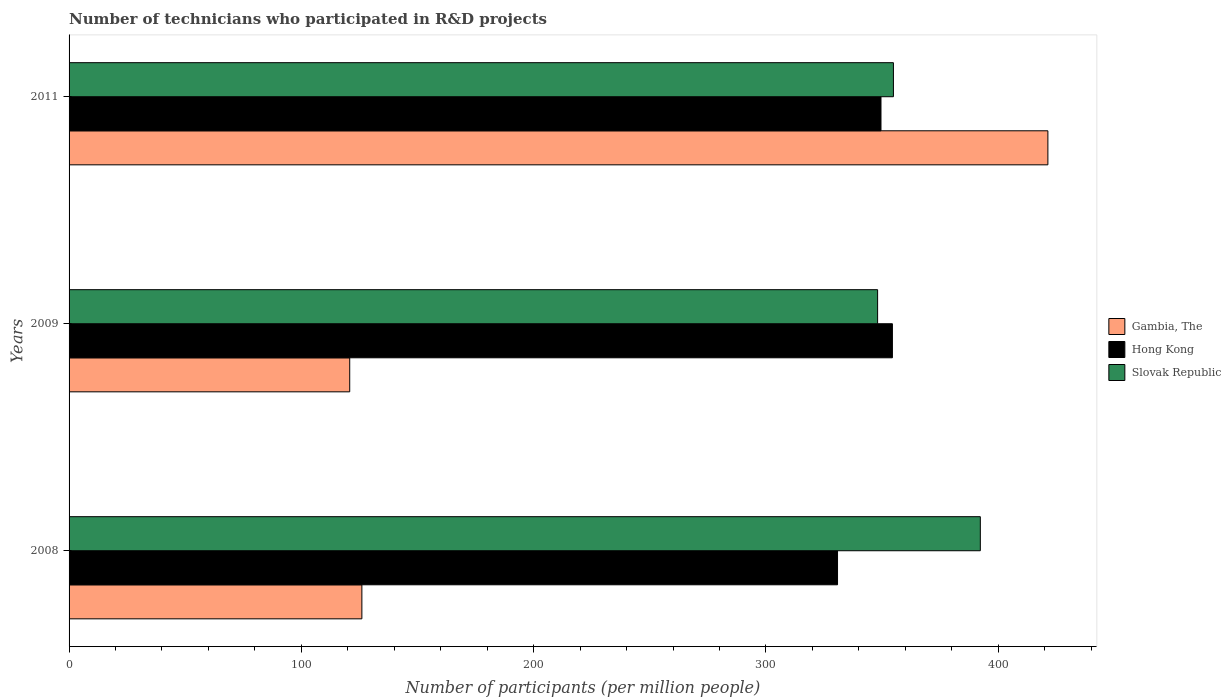How many different coloured bars are there?
Make the answer very short. 3. How many bars are there on the 1st tick from the top?
Offer a terse response. 3. What is the label of the 3rd group of bars from the top?
Make the answer very short. 2008. What is the number of technicians who participated in R&D projects in Hong Kong in 2011?
Keep it short and to the point. 349.51. Across all years, what is the maximum number of technicians who participated in R&D projects in Hong Kong?
Your answer should be very brief. 354.43. Across all years, what is the minimum number of technicians who participated in R&D projects in Gambia, The?
Provide a succinct answer. 120.81. In which year was the number of technicians who participated in R&D projects in Hong Kong maximum?
Ensure brevity in your answer.  2009. What is the total number of technicians who participated in R&D projects in Slovak Republic in the graph?
Offer a very short reply. 1095.2. What is the difference between the number of technicians who participated in R&D projects in Gambia, The in 2009 and that in 2011?
Make the answer very short. -300.55. What is the difference between the number of technicians who participated in R&D projects in Gambia, The in 2011 and the number of technicians who participated in R&D projects in Hong Kong in 2008?
Provide a short and direct response. 90.55. What is the average number of technicians who participated in R&D projects in Gambia, The per year?
Give a very brief answer. 222.74. In the year 2008, what is the difference between the number of technicians who participated in R&D projects in Gambia, The and number of technicians who participated in R&D projects in Hong Kong?
Offer a terse response. -204.76. In how many years, is the number of technicians who participated in R&D projects in Gambia, The greater than 140 ?
Your answer should be very brief. 1. What is the ratio of the number of technicians who participated in R&D projects in Hong Kong in 2008 to that in 2009?
Keep it short and to the point. 0.93. Is the number of technicians who participated in R&D projects in Slovak Republic in 2009 less than that in 2011?
Offer a terse response. Yes. What is the difference between the highest and the second highest number of technicians who participated in R&D projects in Slovak Republic?
Offer a very short reply. 37.41. What is the difference between the highest and the lowest number of technicians who participated in R&D projects in Hong Kong?
Offer a very short reply. 23.62. In how many years, is the number of technicians who participated in R&D projects in Hong Kong greater than the average number of technicians who participated in R&D projects in Hong Kong taken over all years?
Provide a short and direct response. 2. What does the 1st bar from the top in 2011 represents?
Offer a very short reply. Slovak Republic. What does the 2nd bar from the bottom in 2009 represents?
Provide a short and direct response. Hong Kong. Is it the case that in every year, the sum of the number of technicians who participated in R&D projects in Gambia, The and number of technicians who participated in R&D projects in Slovak Republic is greater than the number of technicians who participated in R&D projects in Hong Kong?
Give a very brief answer. Yes. How many years are there in the graph?
Your response must be concise. 3. Does the graph contain any zero values?
Make the answer very short. No. Does the graph contain grids?
Ensure brevity in your answer.  No. How many legend labels are there?
Offer a very short reply. 3. What is the title of the graph?
Provide a short and direct response. Number of technicians who participated in R&D projects. What is the label or title of the X-axis?
Your answer should be compact. Number of participants (per million people). What is the label or title of the Y-axis?
Give a very brief answer. Years. What is the Number of participants (per million people) in Gambia, The in 2008?
Ensure brevity in your answer.  126.04. What is the Number of participants (per million people) of Hong Kong in 2008?
Your answer should be very brief. 330.81. What is the Number of participants (per million people) in Slovak Republic in 2008?
Give a very brief answer. 392.28. What is the Number of participants (per million people) of Gambia, The in 2009?
Provide a succinct answer. 120.81. What is the Number of participants (per million people) in Hong Kong in 2009?
Your answer should be compact. 354.43. What is the Number of participants (per million people) in Slovak Republic in 2009?
Provide a succinct answer. 348.06. What is the Number of participants (per million people) of Gambia, The in 2011?
Your answer should be very brief. 421.36. What is the Number of participants (per million people) of Hong Kong in 2011?
Your response must be concise. 349.51. What is the Number of participants (per million people) of Slovak Republic in 2011?
Your answer should be compact. 354.86. Across all years, what is the maximum Number of participants (per million people) of Gambia, The?
Your response must be concise. 421.36. Across all years, what is the maximum Number of participants (per million people) in Hong Kong?
Provide a short and direct response. 354.43. Across all years, what is the maximum Number of participants (per million people) in Slovak Republic?
Provide a short and direct response. 392.28. Across all years, what is the minimum Number of participants (per million people) of Gambia, The?
Provide a short and direct response. 120.81. Across all years, what is the minimum Number of participants (per million people) of Hong Kong?
Offer a terse response. 330.81. Across all years, what is the minimum Number of participants (per million people) in Slovak Republic?
Your answer should be compact. 348.06. What is the total Number of participants (per million people) in Gambia, The in the graph?
Ensure brevity in your answer.  668.22. What is the total Number of participants (per million people) in Hong Kong in the graph?
Provide a succinct answer. 1034.74. What is the total Number of participants (per million people) of Slovak Republic in the graph?
Provide a short and direct response. 1095.2. What is the difference between the Number of participants (per million people) of Gambia, The in 2008 and that in 2009?
Your response must be concise. 5.23. What is the difference between the Number of participants (per million people) in Hong Kong in 2008 and that in 2009?
Your answer should be compact. -23.62. What is the difference between the Number of participants (per million people) in Slovak Republic in 2008 and that in 2009?
Your answer should be very brief. 44.22. What is the difference between the Number of participants (per million people) in Gambia, The in 2008 and that in 2011?
Your answer should be compact. -295.32. What is the difference between the Number of participants (per million people) in Hong Kong in 2008 and that in 2011?
Provide a succinct answer. -18.7. What is the difference between the Number of participants (per million people) of Slovak Republic in 2008 and that in 2011?
Provide a short and direct response. 37.41. What is the difference between the Number of participants (per million people) of Gambia, The in 2009 and that in 2011?
Keep it short and to the point. -300.55. What is the difference between the Number of participants (per million people) in Hong Kong in 2009 and that in 2011?
Make the answer very short. 4.92. What is the difference between the Number of participants (per million people) of Slovak Republic in 2009 and that in 2011?
Ensure brevity in your answer.  -6.8. What is the difference between the Number of participants (per million people) of Gambia, The in 2008 and the Number of participants (per million people) of Hong Kong in 2009?
Your response must be concise. -228.38. What is the difference between the Number of participants (per million people) of Gambia, The in 2008 and the Number of participants (per million people) of Slovak Republic in 2009?
Provide a succinct answer. -222.02. What is the difference between the Number of participants (per million people) in Hong Kong in 2008 and the Number of participants (per million people) in Slovak Republic in 2009?
Your answer should be very brief. -17.25. What is the difference between the Number of participants (per million people) in Gambia, The in 2008 and the Number of participants (per million people) in Hong Kong in 2011?
Offer a very short reply. -223.46. What is the difference between the Number of participants (per million people) of Gambia, The in 2008 and the Number of participants (per million people) of Slovak Republic in 2011?
Your response must be concise. -228.82. What is the difference between the Number of participants (per million people) in Hong Kong in 2008 and the Number of participants (per million people) in Slovak Republic in 2011?
Provide a short and direct response. -24.06. What is the difference between the Number of participants (per million people) of Gambia, The in 2009 and the Number of participants (per million people) of Hong Kong in 2011?
Your response must be concise. -228.69. What is the difference between the Number of participants (per million people) in Gambia, The in 2009 and the Number of participants (per million people) in Slovak Republic in 2011?
Provide a short and direct response. -234.05. What is the difference between the Number of participants (per million people) of Hong Kong in 2009 and the Number of participants (per million people) of Slovak Republic in 2011?
Ensure brevity in your answer.  -0.44. What is the average Number of participants (per million people) of Gambia, The per year?
Provide a short and direct response. 222.74. What is the average Number of participants (per million people) of Hong Kong per year?
Keep it short and to the point. 344.91. What is the average Number of participants (per million people) in Slovak Republic per year?
Provide a short and direct response. 365.07. In the year 2008, what is the difference between the Number of participants (per million people) of Gambia, The and Number of participants (per million people) of Hong Kong?
Give a very brief answer. -204.76. In the year 2008, what is the difference between the Number of participants (per million people) of Gambia, The and Number of participants (per million people) of Slovak Republic?
Make the answer very short. -266.23. In the year 2008, what is the difference between the Number of participants (per million people) of Hong Kong and Number of participants (per million people) of Slovak Republic?
Your answer should be compact. -61.47. In the year 2009, what is the difference between the Number of participants (per million people) of Gambia, The and Number of participants (per million people) of Hong Kong?
Offer a terse response. -233.61. In the year 2009, what is the difference between the Number of participants (per million people) in Gambia, The and Number of participants (per million people) in Slovak Republic?
Your response must be concise. -227.25. In the year 2009, what is the difference between the Number of participants (per million people) in Hong Kong and Number of participants (per million people) in Slovak Republic?
Offer a very short reply. 6.37. In the year 2011, what is the difference between the Number of participants (per million people) of Gambia, The and Number of participants (per million people) of Hong Kong?
Offer a terse response. 71.85. In the year 2011, what is the difference between the Number of participants (per million people) of Gambia, The and Number of participants (per million people) of Slovak Republic?
Offer a very short reply. 66.5. In the year 2011, what is the difference between the Number of participants (per million people) of Hong Kong and Number of participants (per million people) of Slovak Republic?
Ensure brevity in your answer.  -5.36. What is the ratio of the Number of participants (per million people) in Gambia, The in 2008 to that in 2009?
Offer a very short reply. 1.04. What is the ratio of the Number of participants (per million people) in Hong Kong in 2008 to that in 2009?
Offer a very short reply. 0.93. What is the ratio of the Number of participants (per million people) of Slovak Republic in 2008 to that in 2009?
Make the answer very short. 1.13. What is the ratio of the Number of participants (per million people) in Gambia, The in 2008 to that in 2011?
Your response must be concise. 0.3. What is the ratio of the Number of participants (per million people) of Hong Kong in 2008 to that in 2011?
Your answer should be compact. 0.95. What is the ratio of the Number of participants (per million people) in Slovak Republic in 2008 to that in 2011?
Provide a succinct answer. 1.11. What is the ratio of the Number of participants (per million people) in Gambia, The in 2009 to that in 2011?
Your response must be concise. 0.29. What is the ratio of the Number of participants (per million people) in Hong Kong in 2009 to that in 2011?
Your answer should be very brief. 1.01. What is the ratio of the Number of participants (per million people) in Slovak Republic in 2009 to that in 2011?
Your response must be concise. 0.98. What is the difference between the highest and the second highest Number of participants (per million people) in Gambia, The?
Keep it short and to the point. 295.32. What is the difference between the highest and the second highest Number of participants (per million people) in Hong Kong?
Provide a succinct answer. 4.92. What is the difference between the highest and the second highest Number of participants (per million people) of Slovak Republic?
Your answer should be very brief. 37.41. What is the difference between the highest and the lowest Number of participants (per million people) in Gambia, The?
Offer a very short reply. 300.55. What is the difference between the highest and the lowest Number of participants (per million people) in Hong Kong?
Make the answer very short. 23.62. What is the difference between the highest and the lowest Number of participants (per million people) of Slovak Republic?
Ensure brevity in your answer.  44.22. 